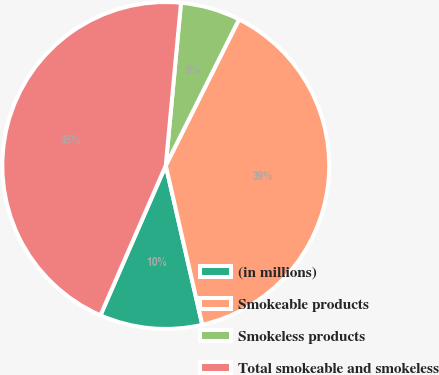Convert chart. <chart><loc_0><loc_0><loc_500><loc_500><pie_chart><fcel>(in millions)<fcel>Smokeable products<fcel>Smokeless products<fcel>Total smokeable and smokeless<nl><fcel>10.13%<fcel>39.02%<fcel>5.91%<fcel>44.94%<nl></chart> 